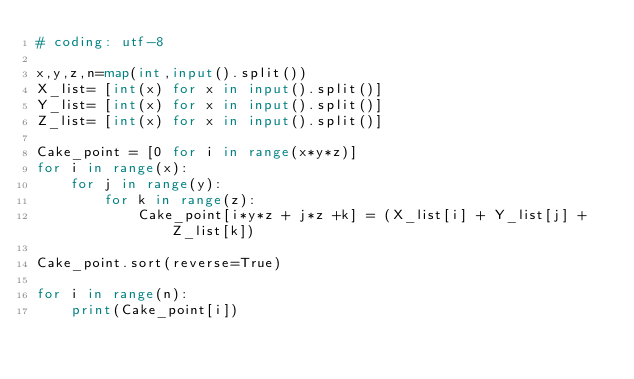<code> <loc_0><loc_0><loc_500><loc_500><_Python_># coding: utf-8

x,y,z,n=map(int,input().split())
X_list= [int(x) for x in input().split()]
Y_list= [int(x) for x in input().split()]
Z_list= [int(x) for x in input().split()]

Cake_point = [0 for i in range(x*y*z)]
for i in range(x):
    for j in range(y):
        for k in range(z):
            Cake_point[i*y*z + j*z +k] = (X_list[i] + Y_list[j] + Z_list[k])

Cake_point.sort(reverse=True)

for i in range(n):
    print(Cake_point[i])
</code> 